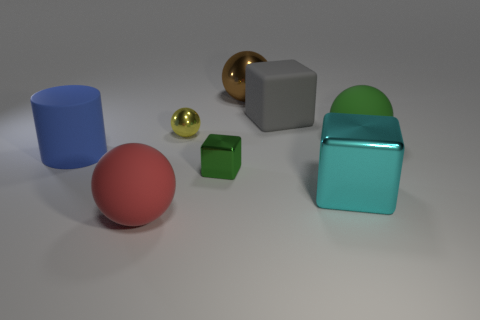Subtract all green rubber spheres. How many spheres are left? 3 Add 2 big yellow cylinders. How many objects exist? 10 Subtract all red spheres. How many spheres are left? 3 Subtract all cubes. How many objects are left? 5 Subtract all big brown shiny cubes. Subtract all small metallic cubes. How many objects are left? 7 Add 5 small yellow metal spheres. How many small yellow metal spheres are left? 6 Add 2 rubber objects. How many rubber objects exist? 6 Subtract 0 gray cylinders. How many objects are left? 8 Subtract 3 cubes. How many cubes are left? 0 Subtract all cyan balls. Subtract all yellow cylinders. How many balls are left? 4 